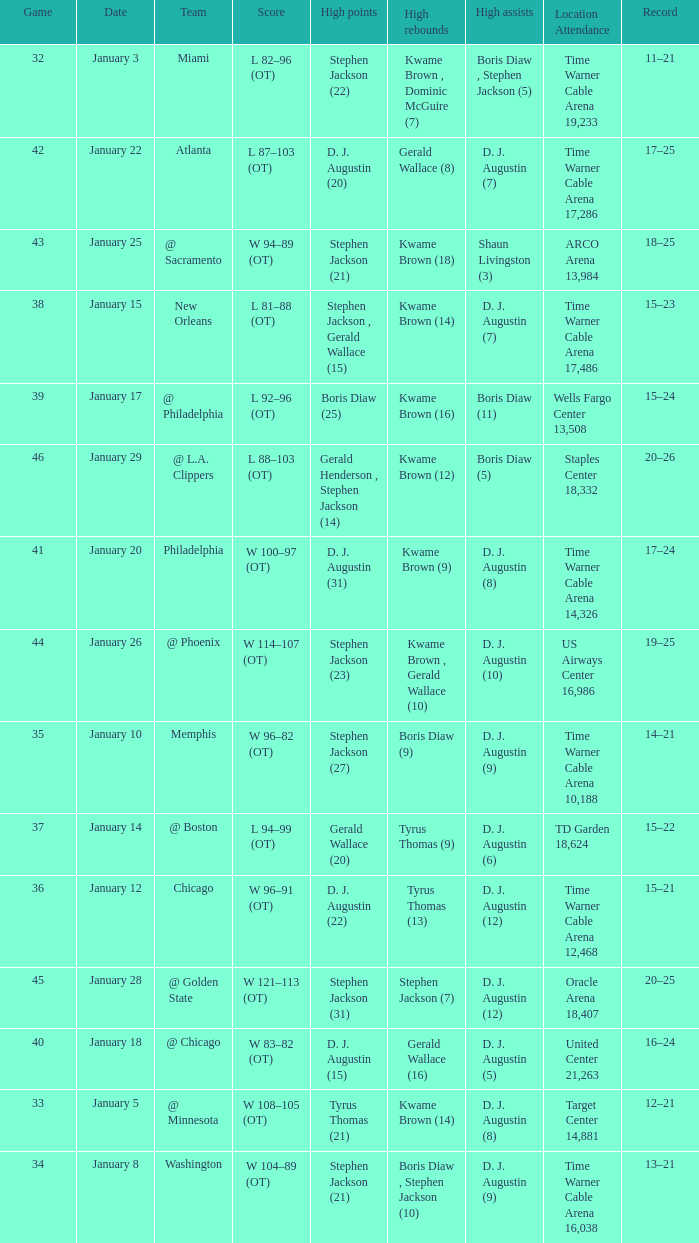How many high rebounds are listed for game 35? 1.0. 